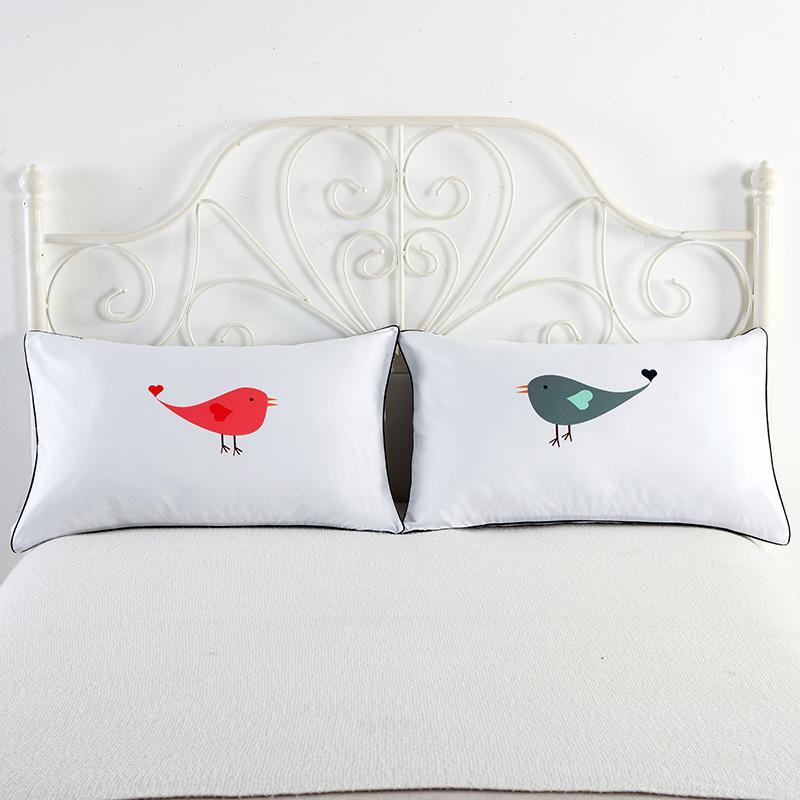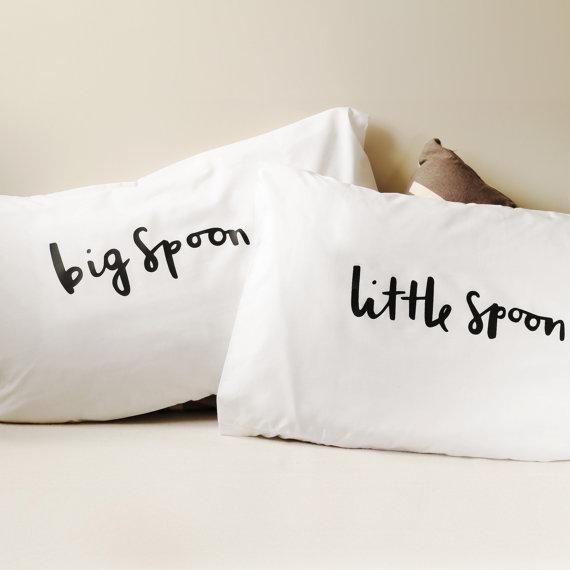The first image is the image on the left, the second image is the image on the right. Analyze the images presented: Is the assertion "In one of the images there are 2 pillows resting against a white headboard." valid? Answer yes or no. Yes. The first image is the image on the left, the second image is the image on the right. Evaluate the accuracy of this statement regarding the images: "The left image contains one rectangular pillow with black text on it, and the right image contains side-by-side pillows printed with black text.". Is it true? Answer yes or no. No. 